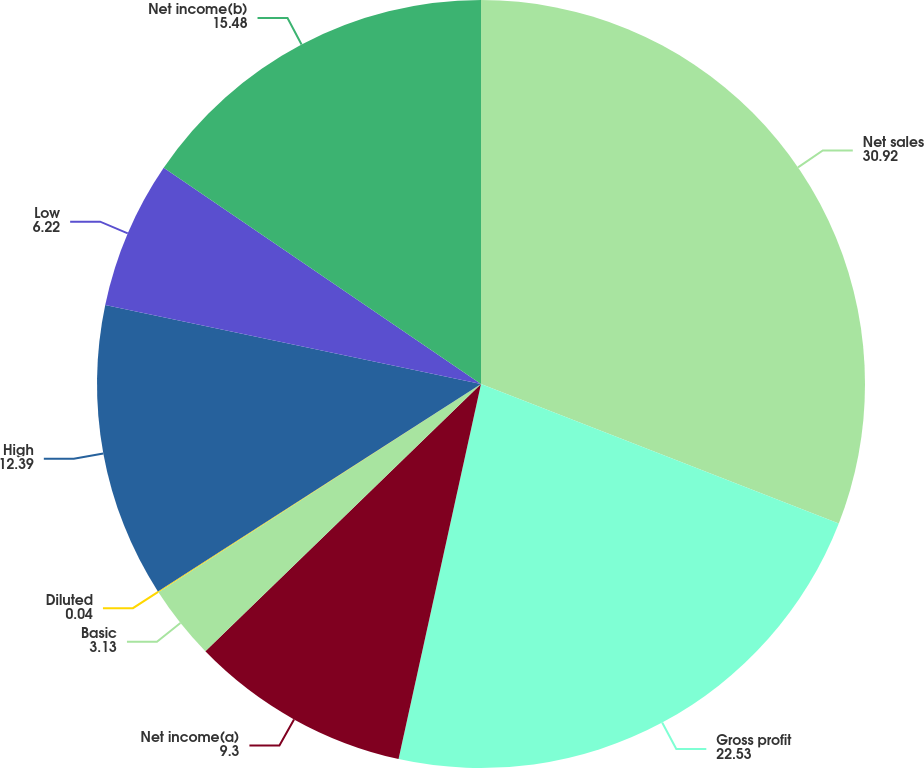Convert chart. <chart><loc_0><loc_0><loc_500><loc_500><pie_chart><fcel>Net sales<fcel>Gross profit<fcel>Net income(a)<fcel>Basic<fcel>Diluted<fcel>High<fcel>Low<fcel>Net income(b)<nl><fcel>30.92%<fcel>22.53%<fcel>9.3%<fcel>3.13%<fcel>0.04%<fcel>12.39%<fcel>6.22%<fcel>15.48%<nl></chart> 